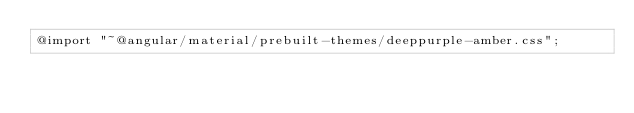Convert code to text. <code><loc_0><loc_0><loc_500><loc_500><_CSS_>@import "~@angular/material/prebuilt-themes/deeppurple-amber.css";</code> 